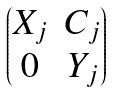Convert formula to latex. <formula><loc_0><loc_0><loc_500><loc_500>\begin{pmatrix} X _ { j } & C _ { j } \\ 0 & Y _ { j } \end{pmatrix}</formula> 